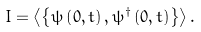Convert formula to latex. <formula><loc_0><loc_0><loc_500><loc_500>I = \left \langle \left \{ \psi \left ( 0 , t \right ) , \psi ^ { \dagger } \left ( 0 , t \right ) \right \} \right \rangle .</formula> 